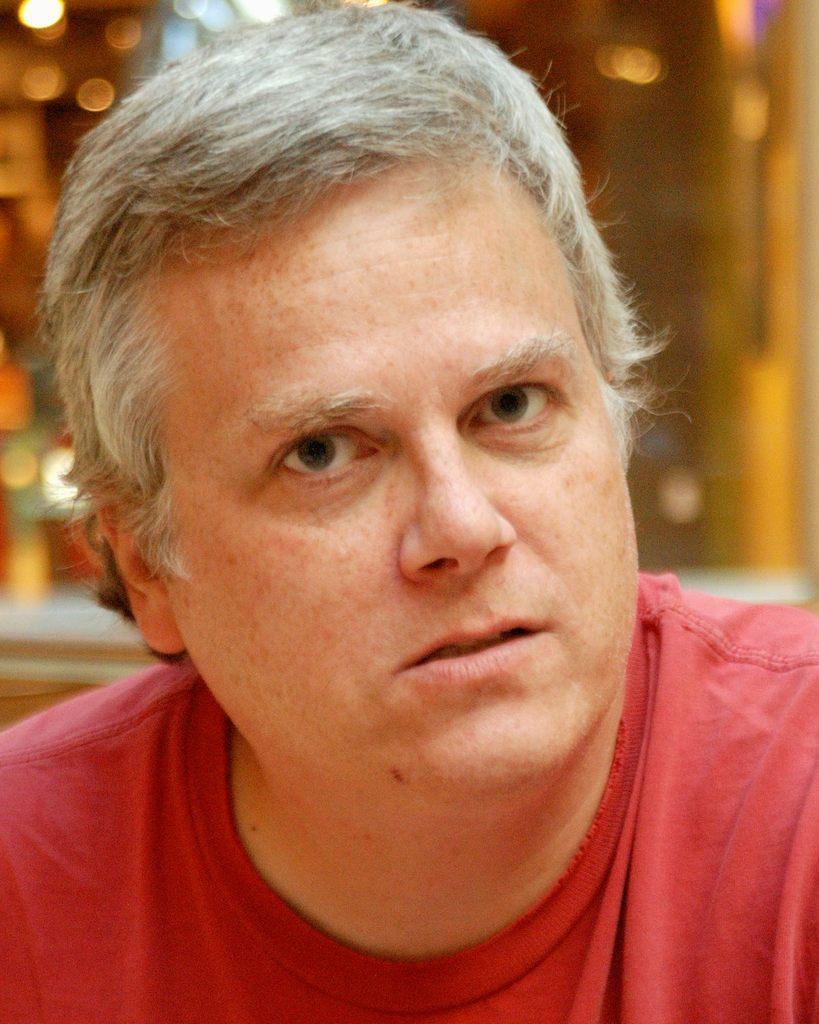Describe this image in one or two sentences. In the center of the image we can see a man. He is wearing a red shirt. In the background there are lights. 